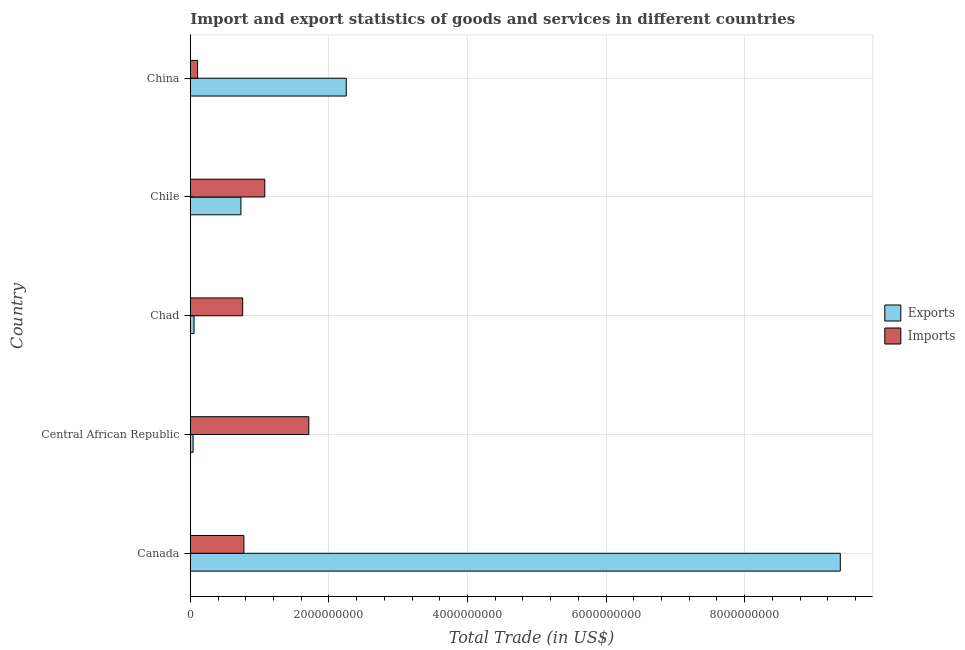How many different coloured bars are there?
Your answer should be very brief. 2. Are the number of bars per tick equal to the number of legend labels?
Your answer should be very brief. Yes. Are the number of bars on each tick of the Y-axis equal?
Your answer should be compact. Yes. What is the label of the 4th group of bars from the top?
Offer a terse response. Central African Republic. In how many cases, is the number of bars for a given country not equal to the number of legend labels?
Your response must be concise. 0. What is the export of goods and services in Canada?
Keep it short and to the point. 9.38e+09. Across all countries, what is the maximum imports of goods and services?
Offer a very short reply. 1.71e+09. Across all countries, what is the minimum export of goods and services?
Give a very brief answer. 4.04e+07. In which country was the export of goods and services maximum?
Offer a terse response. Canada. What is the total imports of goods and services in the graph?
Offer a terse response. 4.42e+09. What is the difference between the export of goods and services in Canada and that in China?
Offer a very short reply. 7.13e+09. What is the difference between the imports of goods and services in Canada and the export of goods and services in Chad?
Your answer should be compact. 7.20e+08. What is the average export of goods and services per country?
Provide a short and direct response. 2.49e+09. What is the difference between the export of goods and services and imports of goods and services in Chile?
Offer a very short reply. -3.44e+08. In how many countries, is the imports of goods and services greater than 800000000 US$?
Your answer should be very brief. 2. What is the ratio of the imports of goods and services in Canada to that in Central African Republic?
Provide a succinct answer. 0.45. What is the difference between the highest and the second highest export of goods and services?
Offer a very short reply. 7.13e+09. What is the difference between the highest and the lowest imports of goods and services?
Make the answer very short. 1.61e+09. In how many countries, is the imports of goods and services greater than the average imports of goods and services taken over all countries?
Give a very brief answer. 2. Is the sum of the imports of goods and services in Central African Republic and Chile greater than the maximum export of goods and services across all countries?
Give a very brief answer. No. What does the 1st bar from the top in Chad represents?
Provide a succinct answer. Imports. What does the 2nd bar from the bottom in Chile represents?
Your response must be concise. Imports. Are all the bars in the graph horizontal?
Keep it short and to the point. Yes. What is the difference between two consecutive major ticks on the X-axis?
Provide a succinct answer. 2.00e+09. Are the values on the major ticks of X-axis written in scientific E-notation?
Your answer should be very brief. No. Does the graph contain grids?
Offer a very short reply. Yes. Where does the legend appear in the graph?
Provide a short and direct response. Center right. How many legend labels are there?
Give a very brief answer. 2. What is the title of the graph?
Provide a succinct answer. Import and export statistics of goods and services in different countries. Does "Food and tobacco" appear as one of the legend labels in the graph?
Your answer should be very brief. No. What is the label or title of the X-axis?
Make the answer very short. Total Trade (in US$). What is the label or title of the Y-axis?
Provide a short and direct response. Country. What is the Total Trade (in US$) of Exports in Canada?
Your response must be concise. 9.38e+09. What is the Total Trade (in US$) of Imports in Canada?
Your response must be concise. 7.74e+08. What is the Total Trade (in US$) in Exports in Central African Republic?
Provide a short and direct response. 4.04e+07. What is the Total Trade (in US$) of Imports in Central African Republic?
Make the answer very short. 1.71e+09. What is the Total Trade (in US$) in Exports in Chad?
Provide a succinct answer. 5.38e+07. What is the Total Trade (in US$) of Imports in Chad?
Offer a very short reply. 7.56e+08. What is the Total Trade (in US$) of Exports in Chile?
Your response must be concise. 7.31e+08. What is the Total Trade (in US$) in Imports in Chile?
Your response must be concise. 1.07e+09. What is the Total Trade (in US$) of Exports in China?
Your answer should be compact. 2.25e+09. What is the Total Trade (in US$) of Imports in China?
Keep it short and to the point. 1.05e+08. Across all countries, what is the maximum Total Trade (in US$) of Exports?
Provide a short and direct response. 9.38e+09. Across all countries, what is the maximum Total Trade (in US$) of Imports?
Keep it short and to the point. 1.71e+09. Across all countries, what is the minimum Total Trade (in US$) in Exports?
Provide a short and direct response. 4.04e+07. Across all countries, what is the minimum Total Trade (in US$) of Imports?
Offer a terse response. 1.05e+08. What is the total Total Trade (in US$) of Exports in the graph?
Your answer should be very brief. 1.25e+1. What is the total Total Trade (in US$) of Imports in the graph?
Offer a terse response. 4.42e+09. What is the difference between the Total Trade (in US$) in Exports in Canada and that in Central African Republic?
Give a very brief answer. 9.34e+09. What is the difference between the Total Trade (in US$) of Imports in Canada and that in Central African Republic?
Your response must be concise. -9.36e+08. What is the difference between the Total Trade (in US$) of Exports in Canada and that in Chad?
Provide a short and direct response. 9.33e+09. What is the difference between the Total Trade (in US$) of Imports in Canada and that in Chad?
Make the answer very short. 1.79e+07. What is the difference between the Total Trade (in US$) of Exports in Canada and that in Chile?
Keep it short and to the point. 8.65e+09. What is the difference between the Total Trade (in US$) in Imports in Canada and that in Chile?
Ensure brevity in your answer.  -3.01e+08. What is the difference between the Total Trade (in US$) in Exports in Canada and that in China?
Provide a short and direct response. 7.13e+09. What is the difference between the Total Trade (in US$) of Imports in Canada and that in China?
Your answer should be compact. 6.69e+08. What is the difference between the Total Trade (in US$) in Exports in Central African Republic and that in Chad?
Offer a very short reply. -1.34e+07. What is the difference between the Total Trade (in US$) in Imports in Central African Republic and that in Chad?
Give a very brief answer. 9.54e+08. What is the difference between the Total Trade (in US$) in Exports in Central African Republic and that in Chile?
Your answer should be very brief. -6.90e+08. What is the difference between the Total Trade (in US$) in Imports in Central African Republic and that in Chile?
Offer a very short reply. 6.35e+08. What is the difference between the Total Trade (in US$) of Exports in Central African Republic and that in China?
Your answer should be very brief. -2.21e+09. What is the difference between the Total Trade (in US$) in Imports in Central African Republic and that in China?
Give a very brief answer. 1.61e+09. What is the difference between the Total Trade (in US$) in Exports in Chad and that in Chile?
Ensure brevity in your answer.  -6.77e+08. What is the difference between the Total Trade (in US$) of Imports in Chad and that in Chile?
Provide a short and direct response. -3.19e+08. What is the difference between the Total Trade (in US$) of Exports in Chad and that in China?
Offer a very short reply. -2.20e+09. What is the difference between the Total Trade (in US$) in Imports in Chad and that in China?
Ensure brevity in your answer.  6.51e+08. What is the difference between the Total Trade (in US$) of Exports in Chile and that in China?
Your answer should be compact. -1.52e+09. What is the difference between the Total Trade (in US$) in Imports in Chile and that in China?
Provide a short and direct response. 9.70e+08. What is the difference between the Total Trade (in US$) in Exports in Canada and the Total Trade (in US$) in Imports in Central African Republic?
Make the answer very short. 7.67e+09. What is the difference between the Total Trade (in US$) in Exports in Canada and the Total Trade (in US$) in Imports in Chad?
Make the answer very short. 8.62e+09. What is the difference between the Total Trade (in US$) of Exports in Canada and the Total Trade (in US$) of Imports in Chile?
Your response must be concise. 8.30e+09. What is the difference between the Total Trade (in US$) in Exports in Canada and the Total Trade (in US$) in Imports in China?
Provide a succinct answer. 9.27e+09. What is the difference between the Total Trade (in US$) in Exports in Central African Republic and the Total Trade (in US$) in Imports in Chad?
Offer a terse response. -7.15e+08. What is the difference between the Total Trade (in US$) in Exports in Central African Republic and the Total Trade (in US$) in Imports in Chile?
Keep it short and to the point. -1.03e+09. What is the difference between the Total Trade (in US$) in Exports in Central African Republic and the Total Trade (in US$) in Imports in China?
Keep it short and to the point. -6.44e+07. What is the difference between the Total Trade (in US$) of Exports in Chad and the Total Trade (in US$) of Imports in Chile?
Give a very brief answer. -1.02e+09. What is the difference between the Total Trade (in US$) in Exports in Chad and the Total Trade (in US$) in Imports in China?
Ensure brevity in your answer.  -5.10e+07. What is the difference between the Total Trade (in US$) of Exports in Chile and the Total Trade (in US$) of Imports in China?
Provide a short and direct response. 6.26e+08. What is the average Total Trade (in US$) of Exports per country?
Your answer should be compact. 2.49e+09. What is the average Total Trade (in US$) of Imports per country?
Make the answer very short. 8.84e+08. What is the difference between the Total Trade (in US$) in Exports and Total Trade (in US$) in Imports in Canada?
Give a very brief answer. 8.61e+09. What is the difference between the Total Trade (in US$) in Exports and Total Trade (in US$) in Imports in Central African Republic?
Offer a very short reply. -1.67e+09. What is the difference between the Total Trade (in US$) in Exports and Total Trade (in US$) in Imports in Chad?
Your answer should be compact. -7.02e+08. What is the difference between the Total Trade (in US$) of Exports and Total Trade (in US$) of Imports in Chile?
Offer a terse response. -3.44e+08. What is the difference between the Total Trade (in US$) in Exports and Total Trade (in US$) in Imports in China?
Offer a terse response. 2.15e+09. What is the ratio of the Total Trade (in US$) of Exports in Canada to that in Central African Republic?
Ensure brevity in your answer.  232.14. What is the ratio of the Total Trade (in US$) of Imports in Canada to that in Central African Republic?
Ensure brevity in your answer.  0.45. What is the ratio of the Total Trade (in US$) in Exports in Canada to that in Chad?
Your answer should be compact. 174.19. What is the ratio of the Total Trade (in US$) of Imports in Canada to that in Chad?
Give a very brief answer. 1.02. What is the ratio of the Total Trade (in US$) in Exports in Canada to that in Chile?
Offer a very short reply. 12.84. What is the ratio of the Total Trade (in US$) in Imports in Canada to that in Chile?
Ensure brevity in your answer.  0.72. What is the ratio of the Total Trade (in US$) in Exports in Canada to that in China?
Give a very brief answer. 4.17. What is the ratio of the Total Trade (in US$) of Imports in Canada to that in China?
Provide a short and direct response. 7.38. What is the ratio of the Total Trade (in US$) in Exports in Central African Republic to that in Chad?
Keep it short and to the point. 0.75. What is the ratio of the Total Trade (in US$) in Imports in Central African Republic to that in Chad?
Make the answer very short. 2.26. What is the ratio of the Total Trade (in US$) of Exports in Central African Republic to that in Chile?
Your answer should be very brief. 0.06. What is the ratio of the Total Trade (in US$) in Imports in Central African Republic to that in Chile?
Offer a very short reply. 1.59. What is the ratio of the Total Trade (in US$) of Exports in Central African Republic to that in China?
Provide a short and direct response. 0.02. What is the ratio of the Total Trade (in US$) in Imports in Central African Republic to that in China?
Keep it short and to the point. 16.31. What is the ratio of the Total Trade (in US$) of Exports in Chad to that in Chile?
Provide a succinct answer. 0.07. What is the ratio of the Total Trade (in US$) of Imports in Chad to that in Chile?
Make the answer very short. 0.7. What is the ratio of the Total Trade (in US$) of Exports in Chad to that in China?
Keep it short and to the point. 0.02. What is the ratio of the Total Trade (in US$) of Imports in Chad to that in China?
Provide a succinct answer. 7.21. What is the ratio of the Total Trade (in US$) in Exports in Chile to that in China?
Keep it short and to the point. 0.32. What is the ratio of the Total Trade (in US$) of Imports in Chile to that in China?
Ensure brevity in your answer.  10.25. What is the difference between the highest and the second highest Total Trade (in US$) of Exports?
Your answer should be compact. 7.13e+09. What is the difference between the highest and the second highest Total Trade (in US$) in Imports?
Your answer should be very brief. 6.35e+08. What is the difference between the highest and the lowest Total Trade (in US$) in Exports?
Keep it short and to the point. 9.34e+09. What is the difference between the highest and the lowest Total Trade (in US$) of Imports?
Keep it short and to the point. 1.61e+09. 